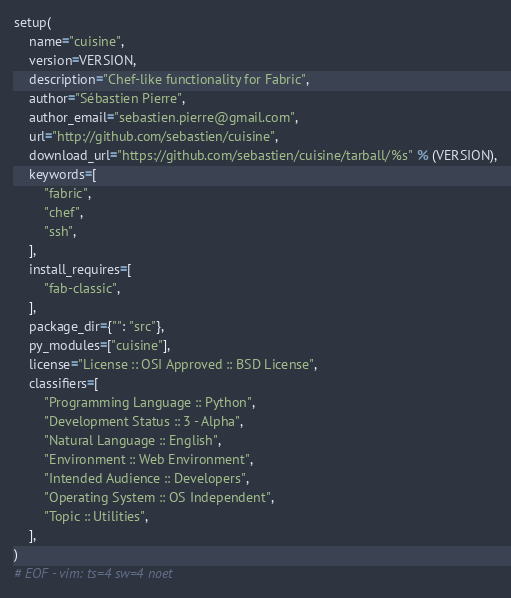Convert code to text. <code><loc_0><loc_0><loc_500><loc_500><_Python_>
setup(
    name="cuisine",
    version=VERSION,
    description="Chef-like functionality for Fabric",
    author="Sébastien Pierre",
    author_email="sebastien.pierre@gmail.com",
    url="http://github.com/sebastien/cuisine",
    download_url="https://github.com/sebastien/cuisine/tarball/%s" % (VERSION),
    keywords=[
        "fabric",
        "chef",
        "ssh",
    ],
    install_requires=[
        "fab-classic",
    ],
    package_dir={"": "src"},
    py_modules=["cuisine"],
    license="License :: OSI Approved :: BSD License",
    classifiers=[
        "Programming Language :: Python",
        "Development Status :: 3 - Alpha",
        "Natural Language :: English",
        "Environment :: Web Environment",
        "Intended Audience :: Developers",
        "Operating System :: OS Independent",
        "Topic :: Utilities",
    ],
)
# EOF - vim: ts=4 sw=4 noet
</code> 